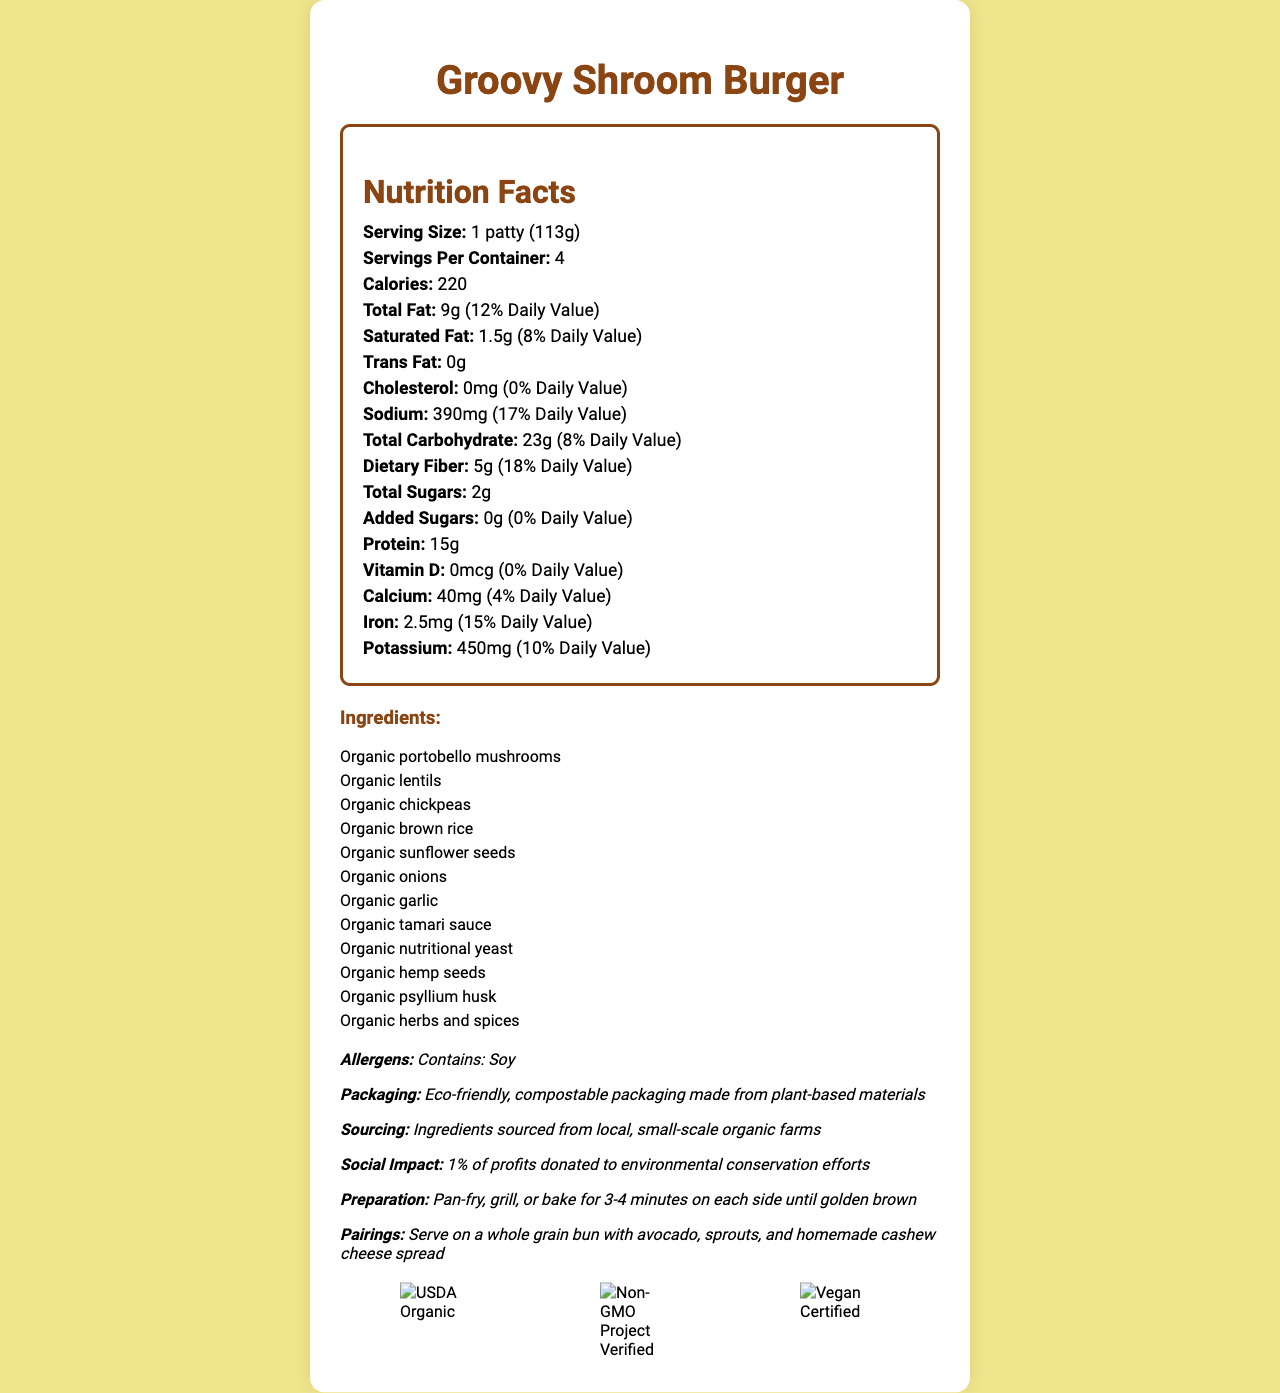what is the serving size of the Groovy Shroom Burger? The serving size is clearly stated as "1 patty (113g)" in the document.
Answer: 1 patty (113g) how many calories are there in one serving? The document states that there are 220 calories per serving.
Answer: 220 how much dietary fiber does one patty contain? According to the nutrition facts, one patty contains 5g of dietary fiber.
Answer: 5g what are the main ingredients found in the Groovy Shroom Burger? These ingredients are listed under the "Ingredients" section in the document.
Answer: Organic portobello mushrooms, Organic lentils, Organic chickpeas, Organic brown rice, Organic sunflower seeds, Organic onions, Organic garlic, Organic tamari sauce, Organic nutritional yeast, Organic hemp seeds, Organic psyllium husk, Organic herbs and spices who benefits from the social impact initiative tied to Groovy Shroom Burger sales? The document mentions that 1% of profits are donated to environmental conservation efforts.
Answer: Environmental conservation efforts what percentage of daily value of iron does one serving provide? One serving provides 15% of the daily value for iron, as stated in the document.
Answer: 15% what is the cholesterol content in the Groovy Shroom Burger? The document shows that the cholesterol content is 0mg.
Answer: 0mg what certifications does the Groovy Shroom Burger have? A. USDA Organic B. Gluten-Free C. Non-GMO Project Verified D. Vegan Certified The product has certifications for USDA Organic, Non-GMO Project Verified, and Vegan Certified. Gluten-Free is not listed.
Answer: A, C, D how should you cook the Groovy Shroom Burger? A. Microwave B. Pan-fry, grill, or bake for 3-4 minutes on each side C. Boil D. Steam The preparation instructions state to pan-fry, grill, or bake for 3-4 minutes on each side until golden brown.
Answer: B is the sodium content high compared to daily value recommendations? yes/no The sodium content is 390 mg, which is 17% of the daily value, relatively high in comparison.
Answer: Yes summarize the key attributes of the Groovy Shroom Burger. The summary includes information about ingredients, nutritional values, certifications, cooking methods, and social impacts of the product.
Answer: The Groovy Shroom Burger is a plant-based meat alternative made from organic mushrooms, legumes, and other ingredients. It contains 220 calories per serving, is high in protein and fiber, and low in cholesterol with eco-friendly packaging. It has certifications for USDA Organic, Non-GMO Project Verified, and Vegan Certified. The product is cooked by pan-frying, grilling, or baking and aims to contribute to environmental conservation efforts. how many different ways can you cook the Groovy Shroom Burger? The document lists three methods: pan-frying, grilling, or baking.
Answer: 3 can you determine the price of the Groovy Shroom Burger based on the document? The document does not provide any information related to the price of the product.
Answer: Not enough information 